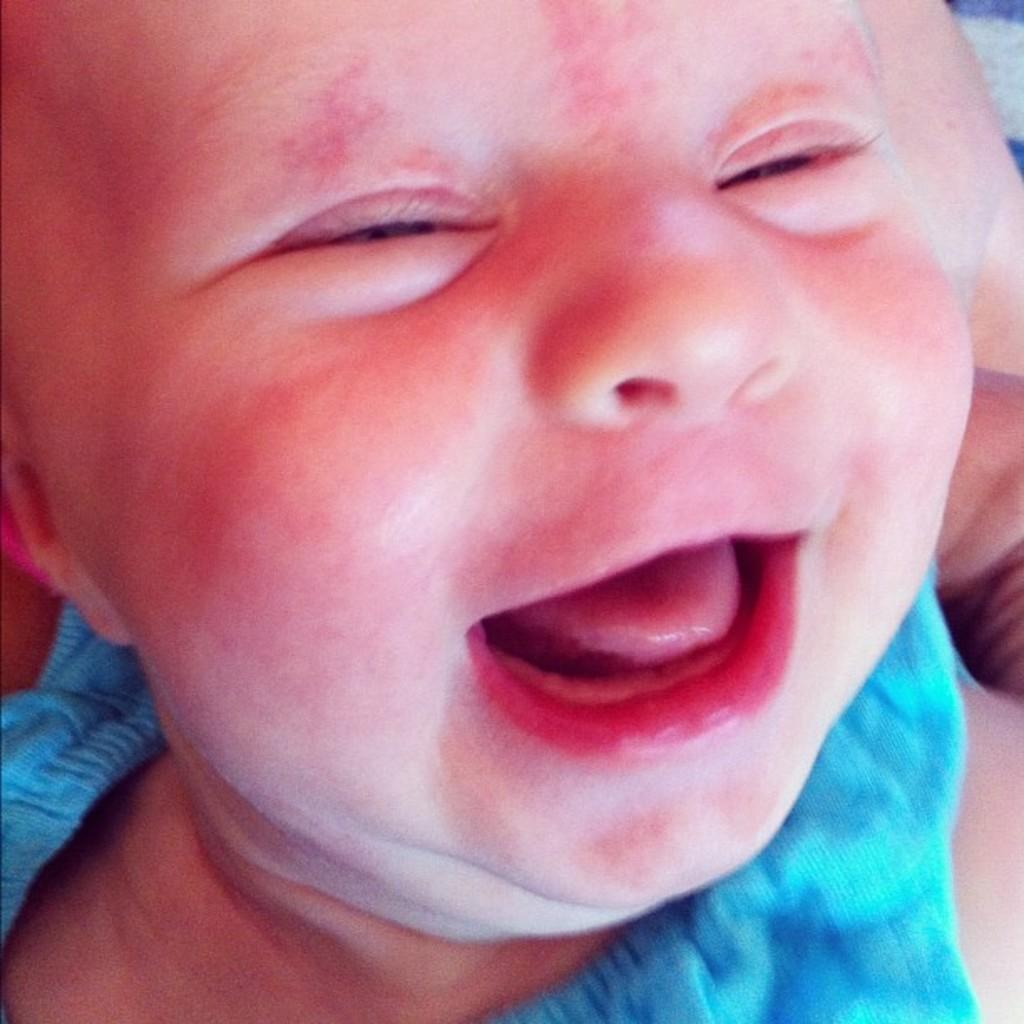What is the main subject of the image? There is a small baby in the image. Can you describe the baby's appearance or position in the image? Unfortunately, the provided facts do not give enough information to describe the baby's appearance or position. What type of soap is the baby using in the image? There is no soap present in the image, as it only features a small baby. 